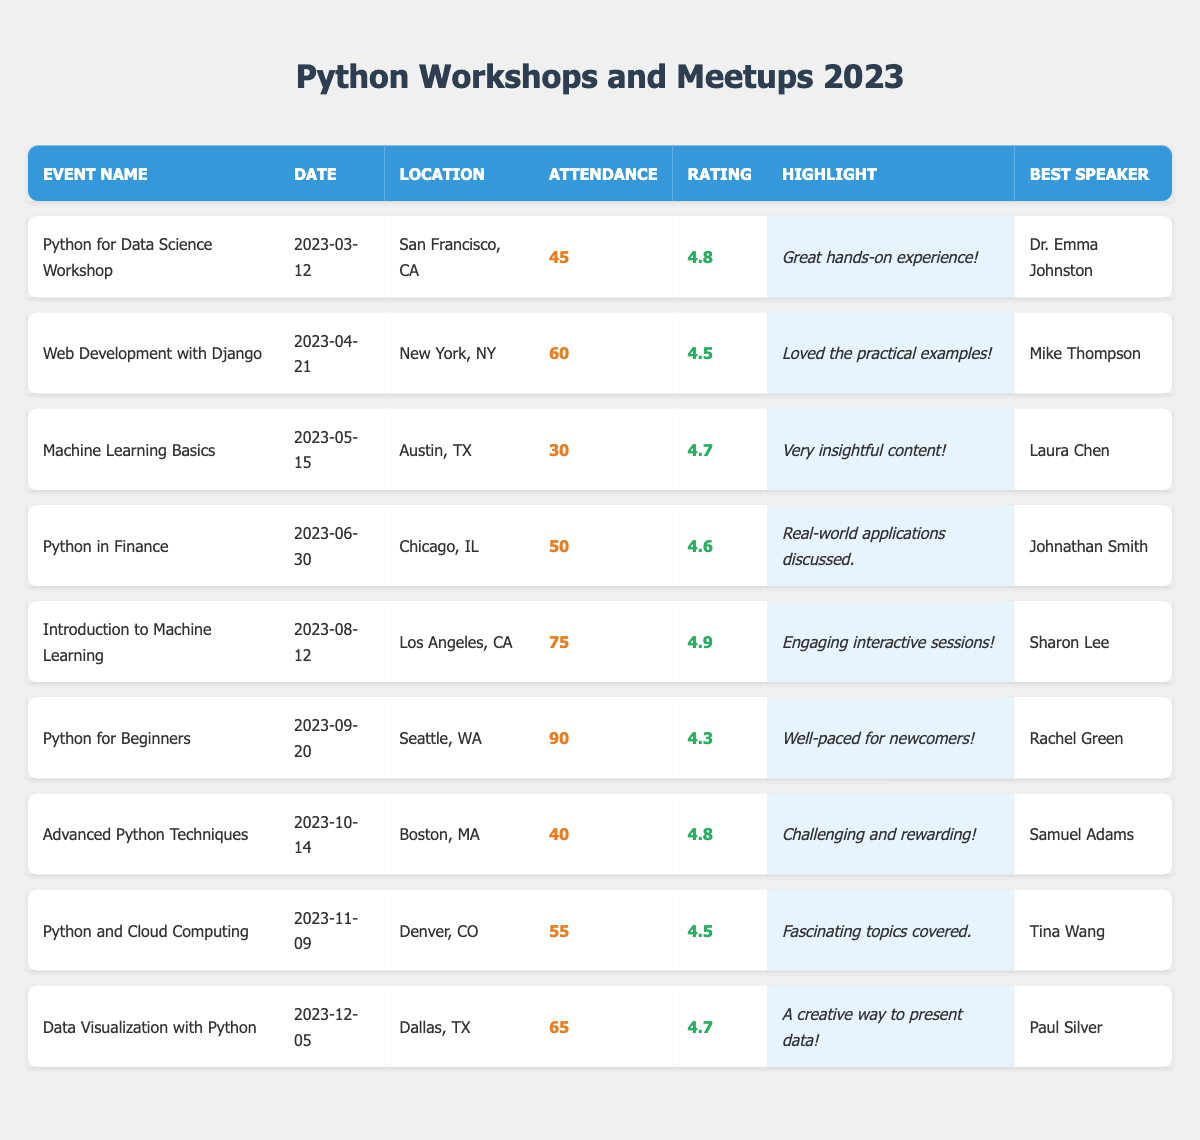What is the date of the "Python for Beginners" event? The date for the "Python for Beginners" event is listed directly in the table under the "Date" column corresponding to that event.
Answer: 2023-09-20 Which event had the highest attendance in 2023? By reviewing the attendance figures listed in the "Attendance" column, "Python for Beginners" shows the highest attendance of 90 people.
Answer: Python for Beginners What is the feedback rating for the "Introduction to Machine Learning" workshop? The feedback rating can be found in the "Rating" column for the "Introduction to Machine Learning" event, which shows a rating of 4.9.
Answer: 4.9 How many events had an attendance of more than 50? By counting the events listed in the "Attendance" column, there are 4 events with attendance above 50, specifically "Web Development with Django," "Introduction to Machine Learning," "Python for Beginners," and "Data Visualization with Python."
Answer: 4 Is there any event that received a feedback rating of 4.5 or lower? Looking at the "Rating" column, "Python for Beginners" has a rating of 4.3, which is indeed 4.5 or lower, confirming that such an event exists.
Answer: Yes What was the average attendance for all the workshops listed? To find the average, sum the attendances of all events (45 + 60 + 30 + 50 + 75 + 90 + 40 + 55 + 65 = 510) and divide by the total number of events (9), giving an average attendance of 510/9 = 56.67.
Answer: 56.67 Which event had the best feedback and who was the speaker? The event with the best feedback rating of 4.9 is "Introduction to Machine Learning," and the best speaker for that event was Sharon Lee, as indicated in the respective columns.
Answer: Introduction to Machine Learning, Sharon Lee What is the difference in attendance between the event with the most and the least attendance? The event with the highest attendance is "Python for Beginners" (90), and the least is "Machine Learning Basics" (30). The difference is 90 - 30 = 60.
Answer: 60 How many speakers received positive feedback based on the highlights of each workshop? Each highlighted feedback in the "Highlight" column is positive. Since each event features a unique speaker, all 9 speakers received positive feedback.
Answer: 9 Which city hosted the event with the lowest attendance? The event with the lowest attendance is "Machine Learning Basics" with 30 attendees, and it was held in Austin, TX, as shown in the "Location" column.
Answer: Austin, TX 